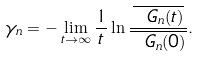<formula> <loc_0><loc_0><loc_500><loc_500>\gamma _ { n } = - \lim _ { t \to \infty } \frac { 1 } { t } \ln { \frac { \overline { { \ G } _ { n } ( t ) } } { { \overline { \ G _ { n } ( 0 ) } } } } .</formula> 